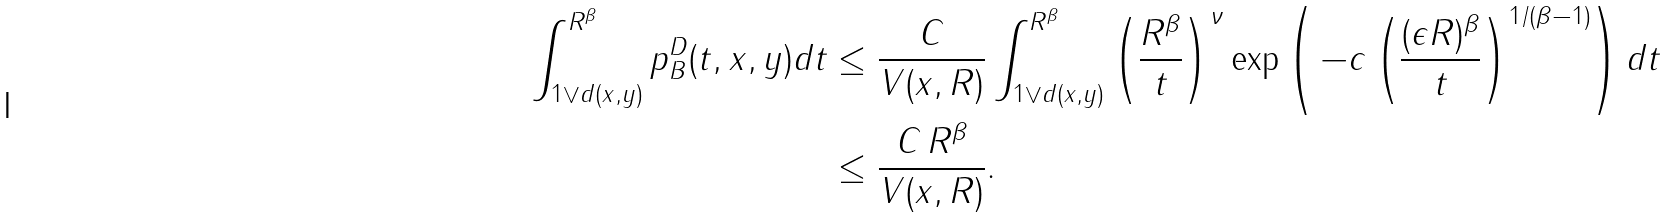<formula> <loc_0><loc_0><loc_500><loc_500>\int _ { 1 \vee d ( x , y ) } ^ { R ^ { \beta } } p ^ { D } _ { B } ( t , x , y ) d t & \leq \frac { C } { V ( x , R ) } \int _ { 1 \vee d ( x , y ) } ^ { R ^ { \beta } } \left ( \frac { R ^ { \beta } } { t } \right ) ^ { \nu } \exp \left ( \, - c \left ( \frac { ( \epsilon R ) ^ { \beta } } { t } \right ) ^ { 1 / ( \beta - 1 ) } \right ) d t \\ & \leq \frac { C \, R ^ { \beta } } { V ( x , R ) } .</formula> 